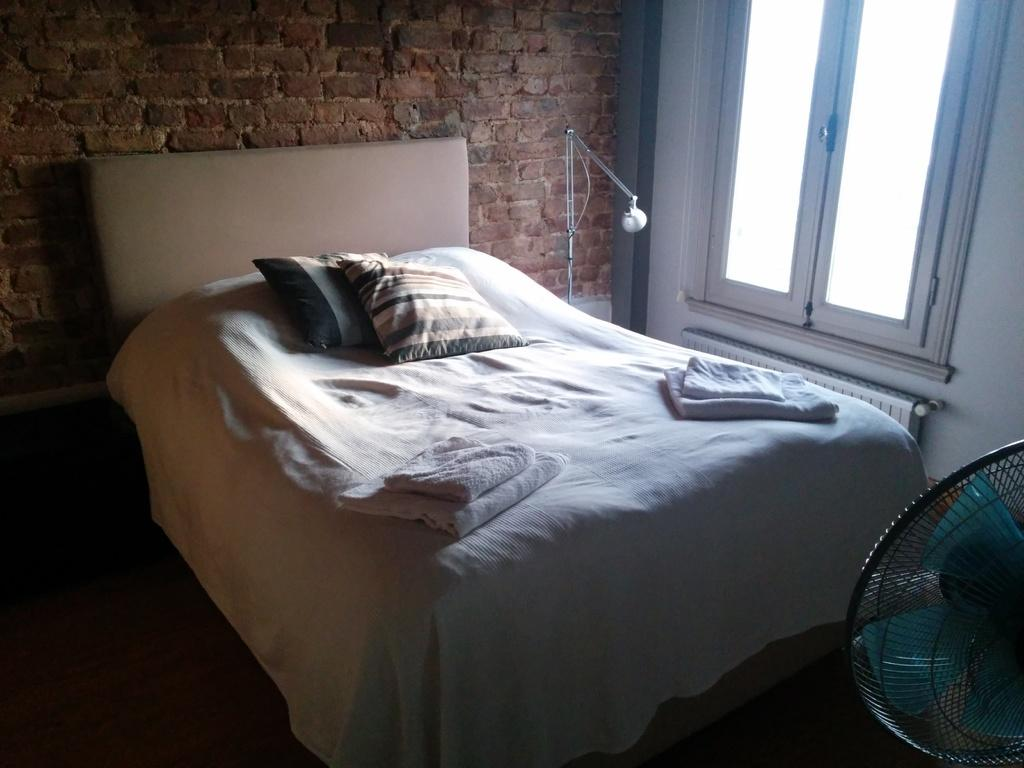What piece of furniture is present in the image? There is a bed in the image. What is placed on the bed? The bed has pillows and blankets on it. What can be seen through the window in the image? The image does not show what can be seen through the window. What source of light is visible in the image? There is a light in the image. What device is present for cooling the room? There is a table fan in the image. What is visible in the background of the image? There is a wall in the background of the image. What type of bird can be seen flying near the window in the image? There is no bird visible in the image. How many mice are hiding under the bed in the image? There is no mention of mice in the image, and it is not possible to determine their presence. 